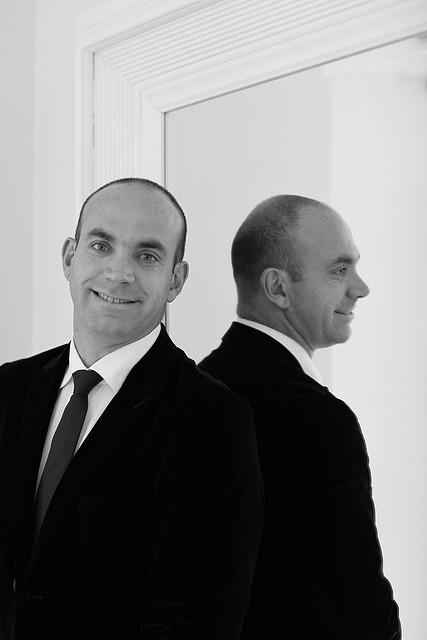Has the man recently shaved?
Keep it brief. Yes. Can he see his reflection?
Keep it brief. No. How many mirrors are there?
Short answer required. 1. 